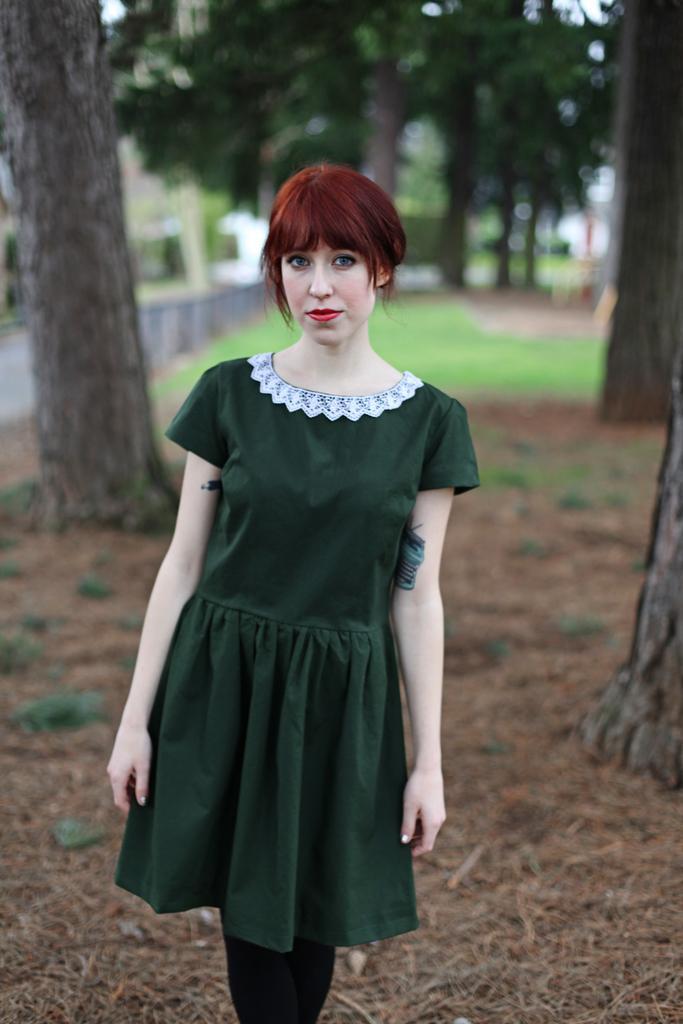Describe this image in one or two sentences. In the picture we can see a woman standing on the surface and she is wearing a green dress and has a brown hair and in the background, we can see some trees, grass and a wall behind to it we can see a house building. 